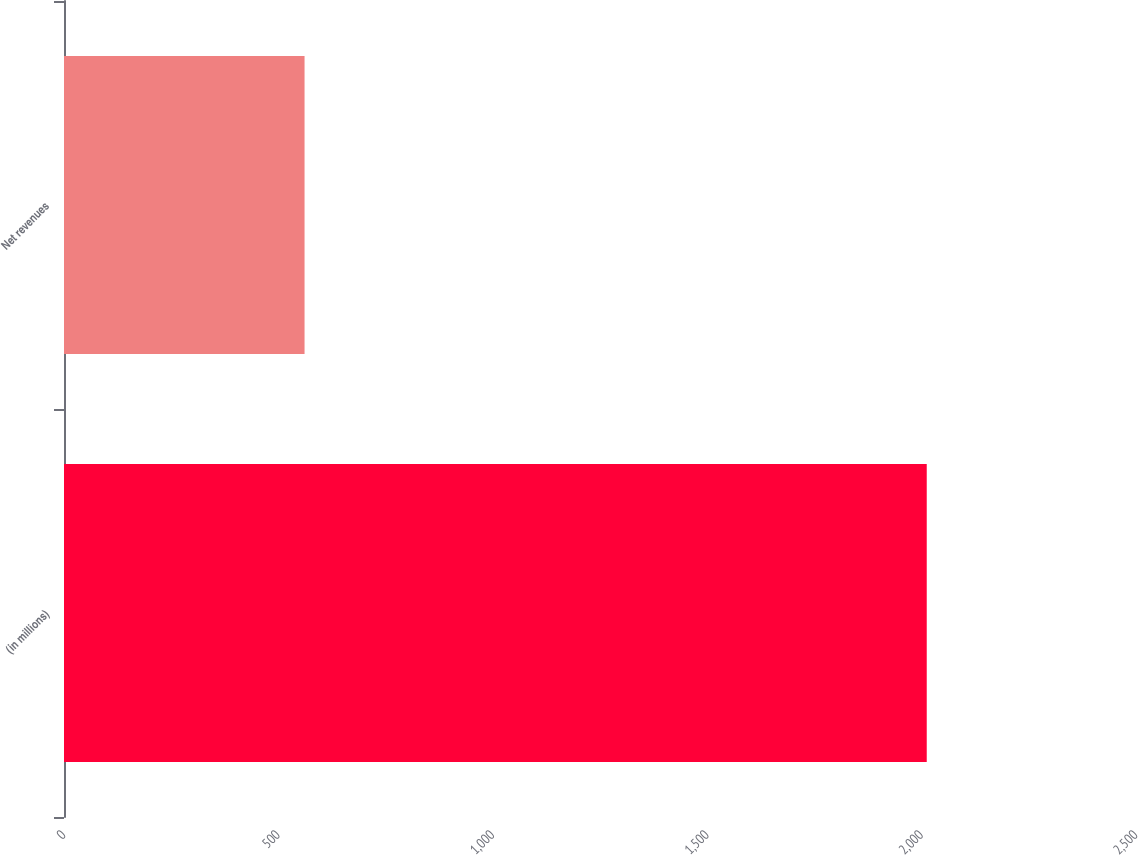Convert chart. <chart><loc_0><loc_0><loc_500><loc_500><bar_chart><fcel>(in millions)<fcel>Net revenues<nl><fcel>2012<fcel>561<nl></chart> 